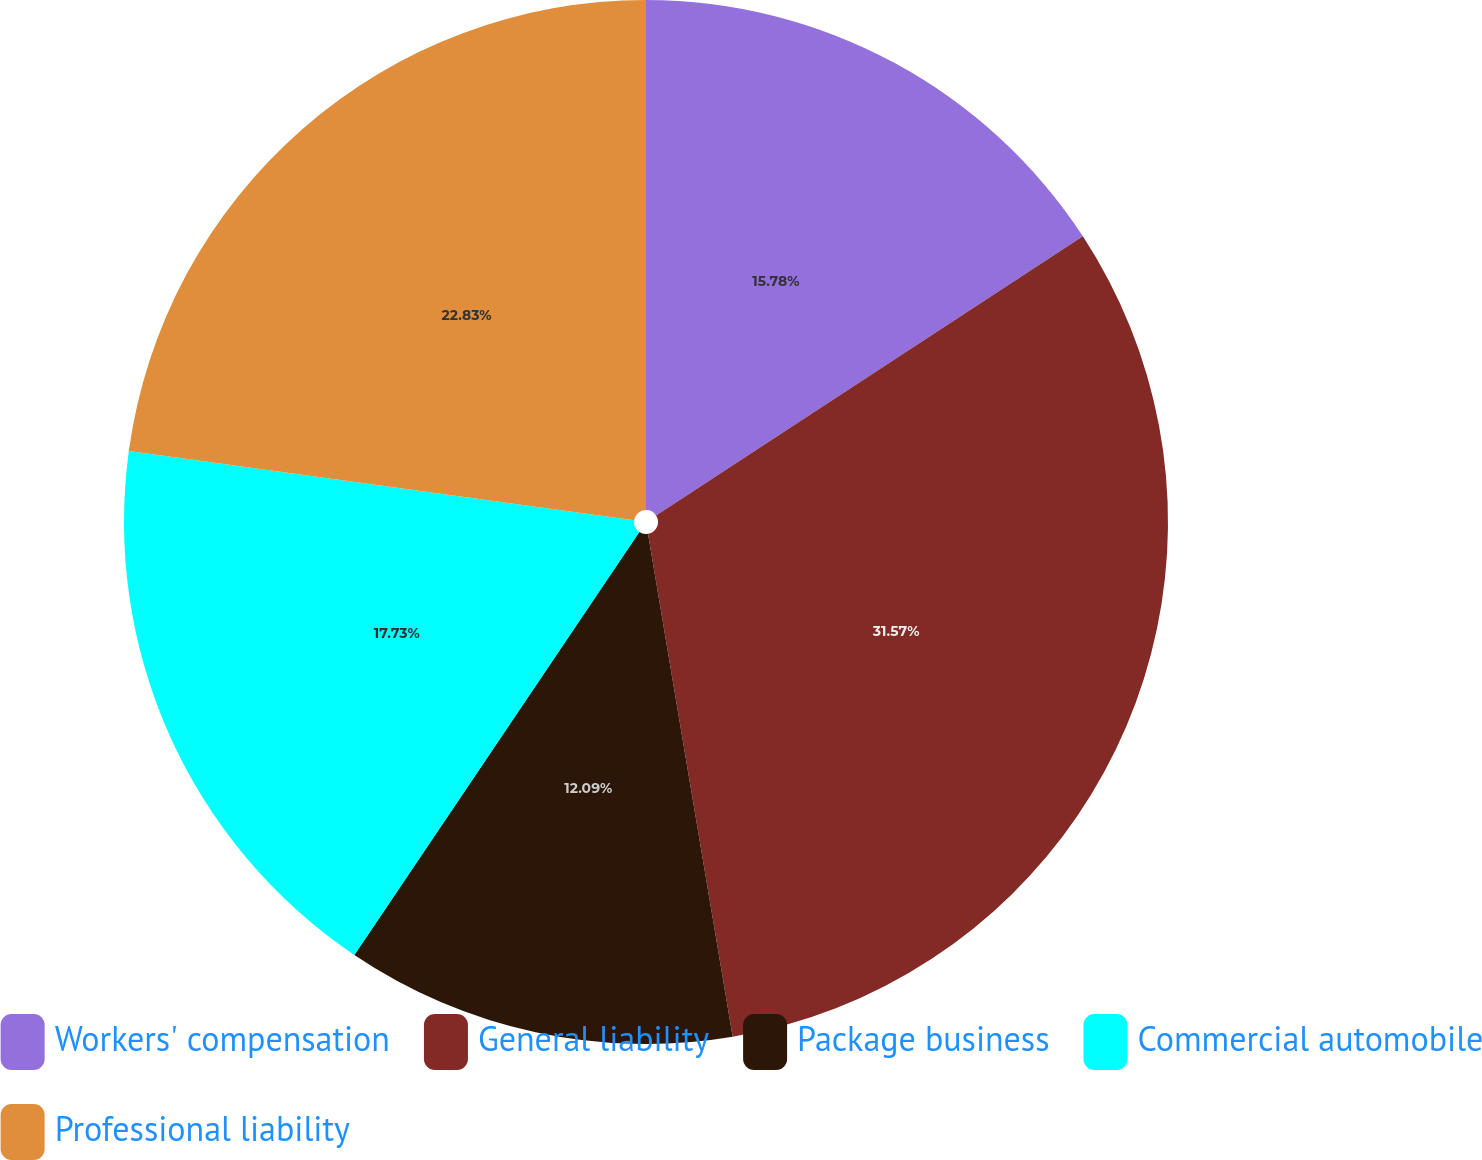<chart> <loc_0><loc_0><loc_500><loc_500><pie_chart><fcel>Workers' compensation<fcel>General liability<fcel>Package business<fcel>Commercial automobile<fcel>Professional liability<nl><fcel>15.78%<fcel>31.56%<fcel>12.09%<fcel>17.73%<fcel>22.83%<nl></chart> 